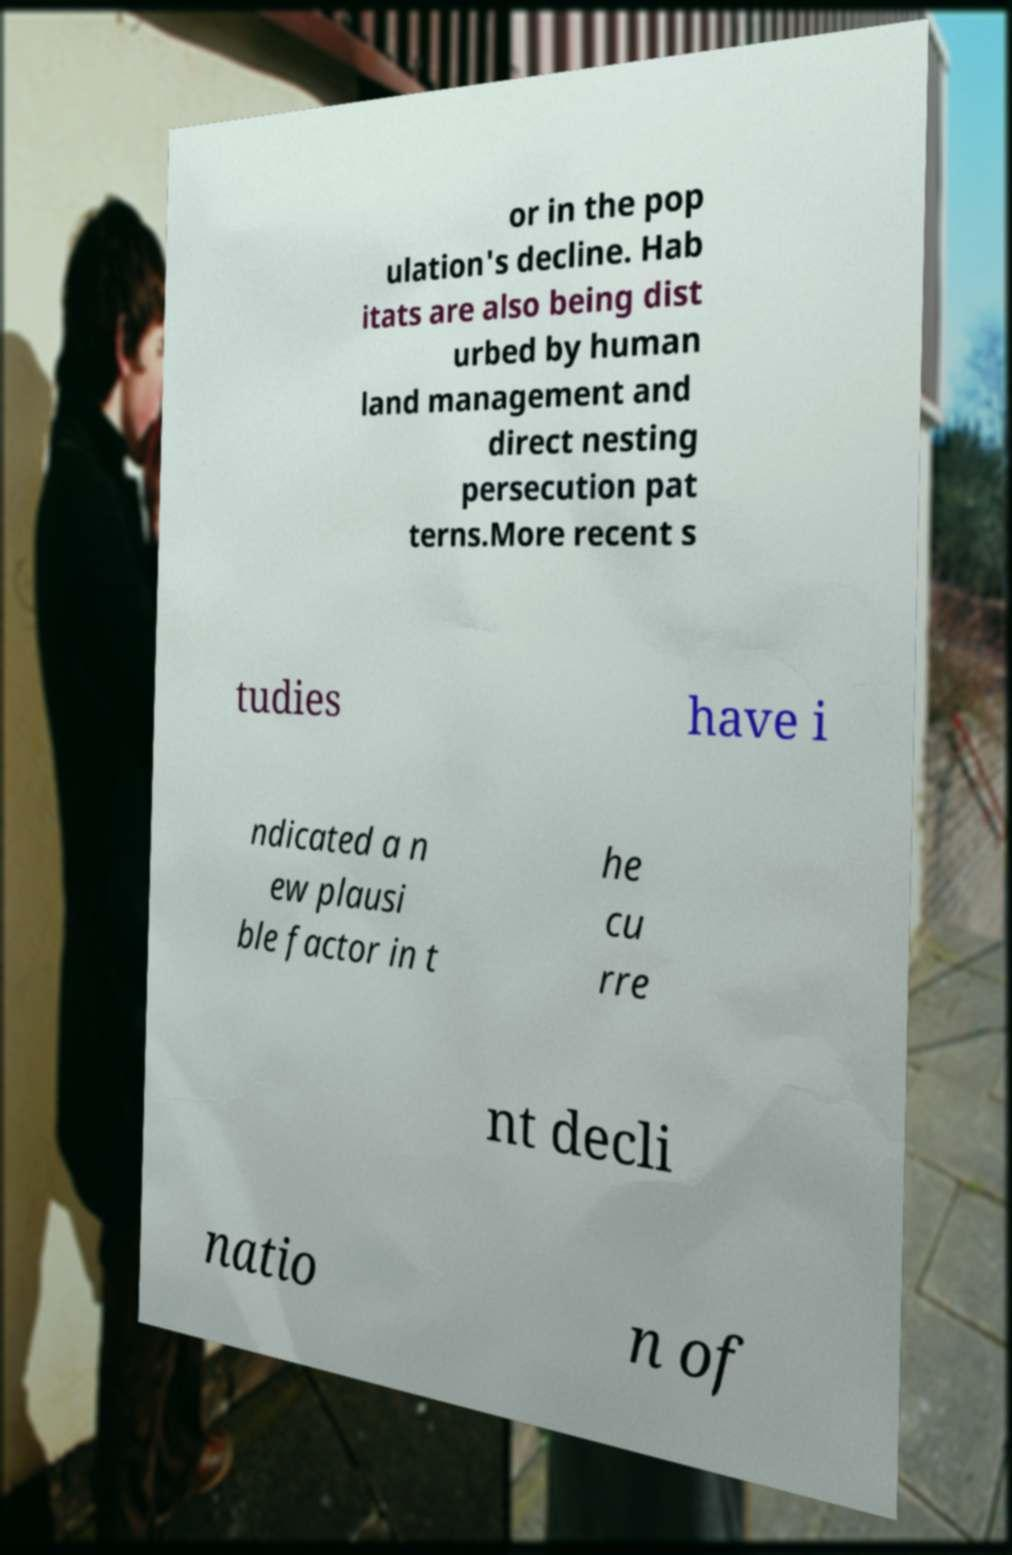Can you read and provide the text displayed in the image?This photo seems to have some interesting text. Can you extract and type it out for me? or in the pop ulation's decline. Hab itats are also being dist urbed by human land management and direct nesting persecution pat terns.More recent s tudies have i ndicated a n ew plausi ble factor in t he cu rre nt decli natio n of 